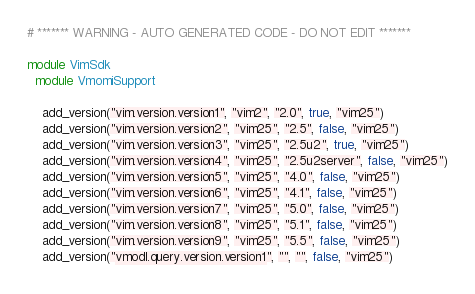<code> <loc_0><loc_0><loc_500><loc_500><_Ruby_># ******* WARNING - AUTO GENERATED CODE - DO NOT EDIT *******

module VimSdk
  module VmomiSupport

    add_version("vim.version.version1", "vim2", "2.0", true, "vim25")
    add_version("vim.version.version2", "vim25", "2.5", false, "vim25")
    add_version("vim.version.version3", "vim25", "2.5u2", true, "vim25")
    add_version("vim.version.version4", "vim25", "2.5u2server", false, "vim25")
    add_version("vim.version.version5", "vim25", "4.0", false, "vim25")
    add_version("vim.version.version6", "vim25", "4.1", false, "vim25")
    add_version("vim.version.version7", "vim25", "5.0", false, "vim25")
    add_version("vim.version.version8", "vim25", "5.1", false, "vim25")
    add_version("vim.version.version9", "vim25", "5.5", false, "vim25")
    add_version("vmodl.query.version.version1", "", "", false, "vim25")</code> 